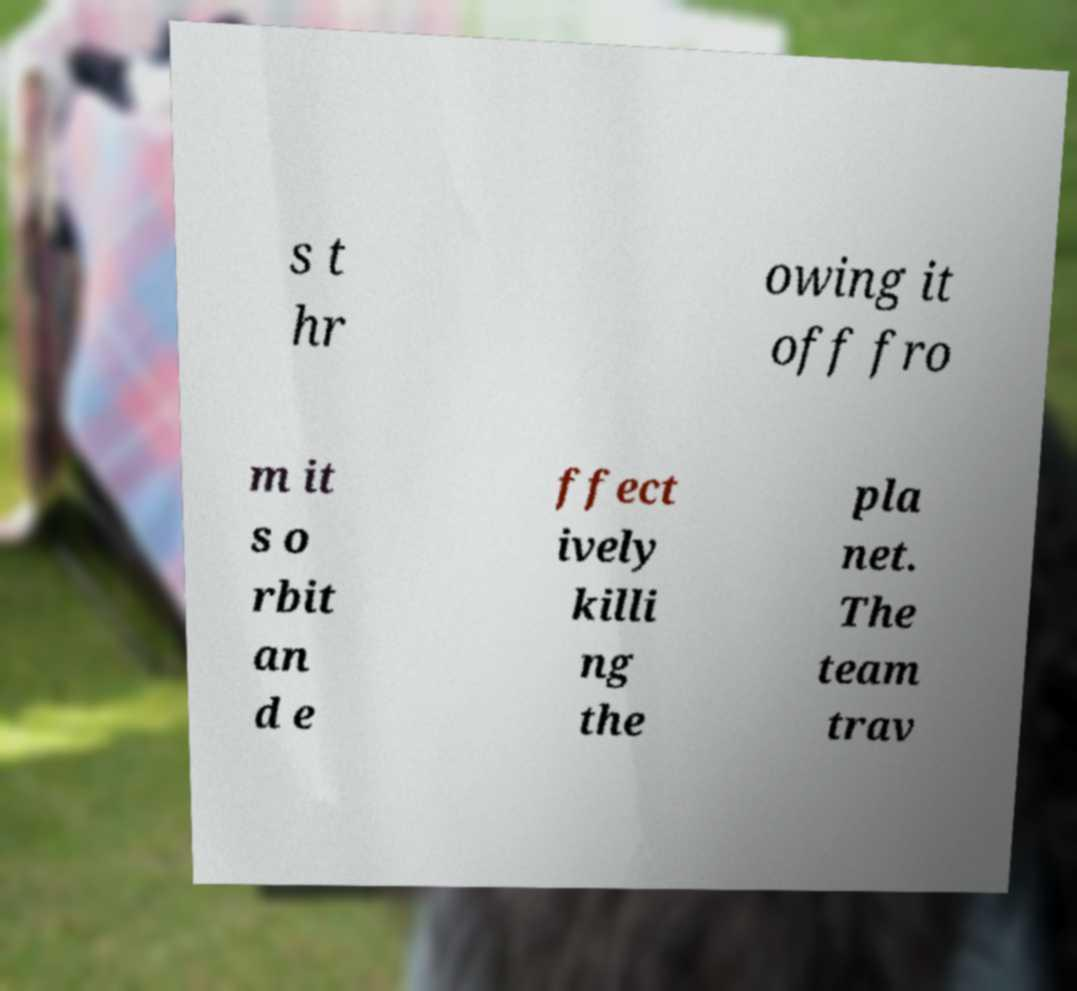Please read and relay the text visible in this image. What does it say? s t hr owing it off fro m it s o rbit an d e ffect ively killi ng the pla net. The team trav 